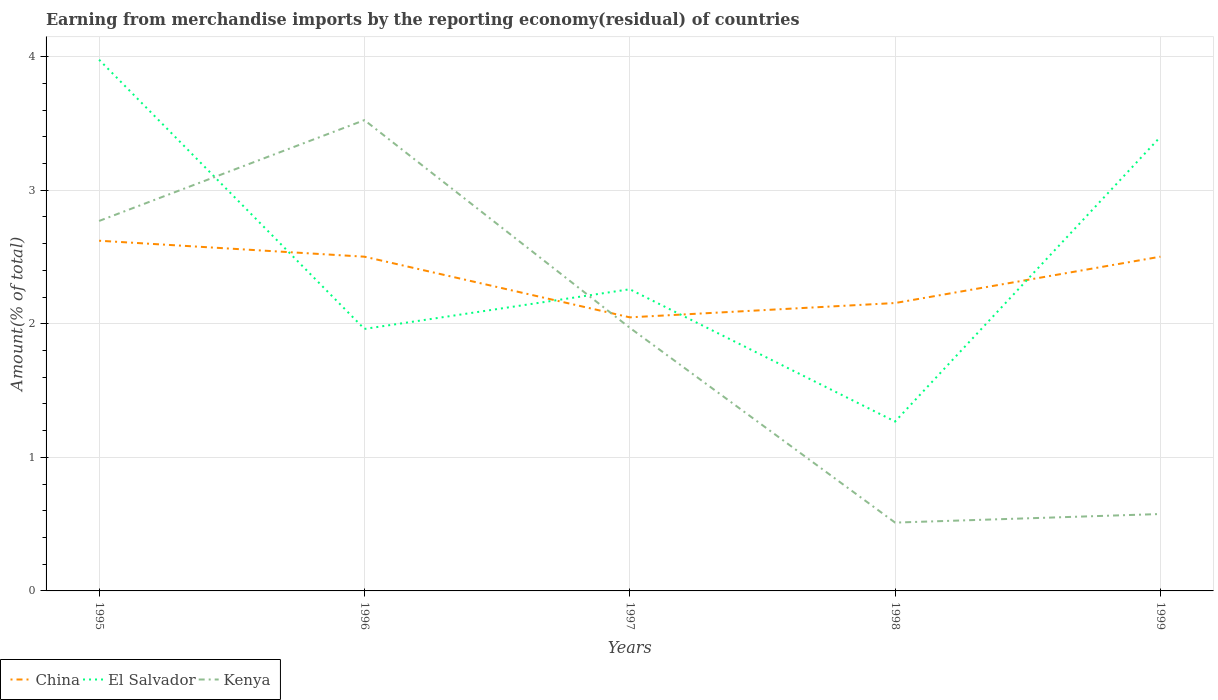Is the number of lines equal to the number of legend labels?
Offer a terse response. Yes. Across all years, what is the maximum percentage of amount earned from merchandise imports in Kenya?
Provide a short and direct response. 0.51. In which year was the percentage of amount earned from merchandise imports in China maximum?
Offer a terse response. 1997. What is the total percentage of amount earned from merchandise imports in Kenya in the graph?
Make the answer very short. 1.55. What is the difference between the highest and the second highest percentage of amount earned from merchandise imports in El Salvador?
Ensure brevity in your answer.  2.71. What is the difference between the highest and the lowest percentage of amount earned from merchandise imports in El Salvador?
Your response must be concise. 2. Is the percentage of amount earned from merchandise imports in El Salvador strictly greater than the percentage of amount earned from merchandise imports in China over the years?
Your answer should be very brief. No. How many lines are there?
Keep it short and to the point. 3. What is the difference between two consecutive major ticks on the Y-axis?
Offer a very short reply. 1. Does the graph contain any zero values?
Offer a terse response. No. Where does the legend appear in the graph?
Make the answer very short. Bottom left. How many legend labels are there?
Ensure brevity in your answer.  3. How are the legend labels stacked?
Provide a succinct answer. Horizontal. What is the title of the graph?
Your response must be concise. Earning from merchandise imports by the reporting economy(residual) of countries. What is the label or title of the Y-axis?
Make the answer very short. Amount(% of total). What is the Amount(% of total) in China in 1995?
Offer a very short reply. 2.62. What is the Amount(% of total) in El Salvador in 1995?
Your answer should be very brief. 3.98. What is the Amount(% of total) of Kenya in 1995?
Provide a short and direct response. 2.77. What is the Amount(% of total) of China in 1996?
Offer a terse response. 2.5. What is the Amount(% of total) of El Salvador in 1996?
Keep it short and to the point. 1.96. What is the Amount(% of total) of Kenya in 1996?
Your answer should be compact. 3.53. What is the Amount(% of total) of China in 1997?
Ensure brevity in your answer.  2.05. What is the Amount(% of total) of El Salvador in 1997?
Your answer should be very brief. 2.26. What is the Amount(% of total) in Kenya in 1997?
Ensure brevity in your answer.  1.97. What is the Amount(% of total) of China in 1998?
Your answer should be compact. 2.16. What is the Amount(% of total) in El Salvador in 1998?
Keep it short and to the point. 1.27. What is the Amount(% of total) of Kenya in 1998?
Ensure brevity in your answer.  0.51. What is the Amount(% of total) of China in 1999?
Your response must be concise. 2.5. What is the Amount(% of total) of El Salvador in 1999?
Offer a very short reply. 3.4. What is the Amount(% of total) of Kenya in 1999?
Keep it short and to the point. 0.58. Across all years, what is the maximum Amount(% of total) in China?
Ensure brevity in your answer.  2.62. Across all years, what is the maximum Amount(% of total) of El Salvador?
Offer a very short reply. 3.98. Across all years, what is the maximum Amount(% of total) of Kenya?
Give a very brief answer. 3.53. Across all years, what is the minimum Amount(% of total) in China?
Ensure brevity in your answer.  2.05. Across all years, what is the minimum Amount(% of total) in El Salvador?
Your answer should be very brief. 1.27. Across all years, what is the minimum Amount(% of total) of Kenya?
Give a very brief answer. 0.51. What is the total Amount(% of total) in China in the graph?
Provide a short and direct response. 11.83. What is the total Amount(% of total) in El Salvador in the graph?
Offer a very short reply. 12.87. What is the total Amount(% of total) in Kenya in the graph?
Provide a succinct answer. 9.35. What is the difference between the Amount(% of total) of China in 1995 and that in 1996?
Offer a terse response. 0.12. What is the difference between the Amount(% of total) of El Salvador in 1995 and that in 1996?
Offer a very short reply. 2.02. What is the difference between the Amount(% of total) in Kenya in 1995 and that in 1996?
Your answer should be very brief. -0.76. What is the difference between the Amount(% of total) in China in 1995 and that in 1997?
Provide a short and direct response. 0.57. What is the difference between the Amount(% of total) in El Salvador in 1995 and that in 1997?
Make the answer very short. 1.72. What is the difference between the Amount(% of total) of Kenya in 1995 and that in 1997?
Your answer should be very brief. 0.8. What is the difference between the Amount(% of total) of China in 1995 and that in 1998?
Provide a succinct answer. 0.47. What is the difference between the Amount(% of total) in El Salvador in 1995 and that in 1998?
Provide a succinct answer. 2.71. What is the difference between the Amount(% of total) of Kenya in 1995 and that in 1998?
Ensure brevity in your answer.  2.26. What is the difference between the Amount(% of total) in China in 1995 and that in 1999?
Make the answer very short. 0.12. What is the difference between the Amount(% of total) in El Salvador in 1995 and that in 1999?
Ensure brevity in your answer.  0.58. What is the difference between the Amount(% of total) in Kenya in 1995 and that in 1999?
Provide a short and direct response. 2.19. What is the difference between the Amount(% of total) of China in 1996 and that in 1997?
Your answer should be compact. 0.45. What is the difference between the Amount(% of total) of El Salvador in 1996 and that in 1997?
Your answer should be very brief. -0.3. What is the difference between the Amount(% of total) in Kenya in 1996 and that in 1997?
Your answer should be very brief. 1.55. What is the difference between the Amount(% of total) in China in 1996 and that in 1998?
Your answer should be compact. 0.35. What is the difference between the Amount(% of total) of El Salvador in 1996 and that in 1998?
Keep it short and to the point. 0.69. What is the difference between the Amount(% of total) in Kenya in 1996 and that in 1998?
Your answer should be very brief. 3.01. What is the difference between the Amount(% of total) of China in 1996 and that in 1999?
Provide a short and direct response. -0. What is the difference between the Amount(% of total) of El Salvador in 1996 and that in 1999?
Make the answer very short. -1.44. What is the difference between the Amount(% of total) in Kenya in 1996 and that in 1999?
Give a very brief answer. 2.95. What is the difference between the Amount(% of total) in China in 1997 and that in 1998?
Provide a short and direct response. -0.11. What is the difference between the Amount(% of total) in El Salvador in 1997 and that in 1998?
Your answer should be very brief. 0.99. What is the difference between the Amount(% of total) in Kenya in 1997 and that in 1998?
Make the answer very short. 1.46. What is the difference between the Amount(% of total) of China in 1997 and that in 1999?
Provide a short and direct response. -0.45. What is the difference between the Amount(% of total) of El Salvador in 1997 and that in 1999?
Your answer should be compact. -1.14. What is the difference between the Amount(% of total) in Kenya in 1997 and that in 1999?
Your response must be concise. 1.39. What is the difference between the Amount(% of total) of China in 1998 and that in 1999?
Offer a terse response. -0.35. What is the difference between the Amount(% of total) of El Salvador in 1998 and that in 1999?
Offer a very short reply. -2.13. What is the difference between the Amount(% of total) of Kenya in 1998 and that in 1999?
Your response must be concise. -0.06. What is the difference between the Amount(% of total) of China in 1995 and the Amount(% of total) of El Salvador in 1996?
Offer a very short reply. 0.66. What is the difference between the Amount(% of total) of China in 1995 and the Amount(% of total) of Kenya in 1996?
Offer a terse response. -0.9. What is the difference between the Amount(% of total) in El Salvador in 1995 and the Amount(% of total) in Kenya in 1996?
Make the answer very short. 0.45. What is the difference between the Amount(% of total) in China in 1995 and the Amount(% of total) in El Salvador in 1997?
Offer a terse response. 0.36. What is the difference between the Amount(% of total) of China in 1995 and the Amount(% of total) of Kenya in 1997?
Your answer should be very brief. 0.65. What is the difference between the Amount(% of total) in El Salvador in 1995 and the Amount(% of total) in Kenya in 1997?
Ensure brevity in your answer.  2.01. What is the difference between the Amount(% of total) of China in 1995 and the Amount(% of total) of El Salvador in 1998?
Your answer should be compact. 1.35. What is the difference between the Amount(% of total) of China in 1995 and the Amount(% of total) of Kenya in 1998?
Provide a succinct answer. 2.11. What is the difference between the Amount(% of total) in El Salvador in 1995 and the Amount(% of total) in Kenya in 1998?
Make the answer very short. 3.47. What is the difference between the Amount(% of total) in China in 1995 and the Amount(% of total) in El Salvador in 1999?
Ensure brevity in your answer.  -0.78. What is the difference between the Amount(% of total) in China in 1995 and the Amount(% of total) in Kenya in 1999?
Offer a very short reply. 2.05. What is the difference between the Amount(% of total) of El Salvador in 1995 and the Amount(% of total) of Kenya in 1999?
Offer a terse response. 3.4. What is the difference between the Amount(% of total) in China in 1996 and the Amount(% of total) in El Salvador in 1997?
Make the answer very short. 0.24. What is the difference between the Amount(% of total) of China in 1996 and the Amount(% of total) of Kenya in 1997?
Provide a succinct answer. 0.53. What is the difference between the Amount(% of total) of El Salvador in 1996 and the Amount(% of total) of Kenya in 1997?
Provide a succinct answer. -0.01. What is the difference between the Amount(% of total) of China in 1996 and the Amount(% of total) of El Salvador in 1998?
Your response must be concise. 1.23. What is the difference between the Amount(% of total) of China in 1996 and the Amount(% of total) of Kenya in 1998?
Make the answer very short. 1.99. What is the difference between the Amount(% of total) in El Salvador in 1996 and the Amount(% of total) in Kenya in 1998?
Offer a very short reply. 1.45. What is the difference between the Amount(% of total) in China in 1996 and the Amount(% of total) in El Salvador in 1999?
Offer a terse response. -0.9. What is the difference between the Amount(% of total) of China in 1996 and the Amount(% of total) of Kenya in 1999?
Your response must be concise. 1.93. What is the difference between the Amount(% of total) in El Salvador in 1996 and the Amount(% of total) in Kenya in 1999?
Your response must be concise. 1.39. What is the difference between the Amount(% of total) in China in 1997 and the Amount(% of total) in El Salvador in 1998?
Provide a succinct answer. 0.78. What is the difference between the Amount(% of total) of China in 1997 and the Amount(% of total) of Kenya in 1998?
Keep it short and to the point. 1.54. What is the difference between the Amount(% of total) of El Salvador in 1997 and the Amount(% of total) of Kenya in 1998?
Offer a very short reply. 1.75. What is the difference between the Amount(% of total) of China in 1997 and the Amount(% of total) of El Salvador in 1999?
Offer a terse response. -1.35. What is the difference between the Amount(% of total) of China in 1997 and the Amount(% of total) of Kenya in 1999?
Your answer should be very brief. 1.47. What is the difference between the Amount(% of total) of El Salvador in 1997 and the Amount(% of total) of Kenya in 1999?
Provide a succinct answer. 1.68. What is the difference between the Amount(% of total) in China in 1998 and the Amount(% of total) in El Salvador in 1999?
Ensure brevity in your answer.  -1.24. What is the difference between the Amount(% of total) in China in 1998 and the Amount(% of total) in Kenya in 1999?
Keep it short and to the point. 1.58. What is the difference between the Amount(% of total) of El Salvador in 1998 and the Amount(% of total) of Kenya in 1999?
Make the answer very short. 0.69. What is the average Amount(% of total) in China per year?
Make the answer very short. 2.37. What is the average Amount(% of total) in El Salvador per year?
Keep it short and to the point. 2.57. What is the average Amount(% of total) of Kenya per year?
Your response must be concise. 1.87. In the year 1995, what is the difference between the Amount(% of total) of China and Amount(% of total) of El Salvador?
Give a very brief answer. -1.36. In the year 1995, what is the difference between the Amount(% of total) in China and Amount(% of total) in Kenya?
Your answer should be very brief. -0.15. In the year 1995, what is the difference between the Amount(% of total) in El Salvador and Amount(% of total) in Kenya?
Provide a short and direct response. 1.21. In the year 1996, what is the difference between the Amount(% of total) in China and Amount(% of total) in El Salvador?
Ensure brevity in your answer.  0.54. In the year 1996, what is the difference between the Amount(% of total) in China and Amount(% of total) in Kenya?
Offer a very short reply. -1.02. In the year 1996, what is the difference between the Amount(% of total) in El Salvador and Amount(% of total) in Kenya?
Offer a very short reply. -1.56. In the year 1997, what is the difference between the Amount(% of total) of China and Amount(% of total) of El Salvador?
Offer a terse response. -0.21. In the year 1997, what is the difference between the Amount(% of total) in China and Amount(% of total) in Kenya?
Give a very brief answer. 0.08. In the year 1997, what is the difference between the Amount(% of total) in El Salvador and Amount(% of total) in Kenya?
Keep it short and to the point. 0.29. In the year 1998, what is the difference between the Amount(% of total) of China and Amount(% of total) of El Salvador?
Keep it short and to the point. 0.89. In the year 1998, what is the difference between the Amount(% of total) of China and Amount(% of total) of Kenya?
Keep it short and to the point. 1.64. In the year 1998, what is the difference between the Amount(% of total) of El Salvador and Amount(% of total) of Kenya?
Make the answer very short. 0.76. In the year 1999, what is the difference between the Amount(% of total) in China and Amount(% of total) in El Salvador?
Give a very brief answer. -0.9. In the year 1999, what is the difference between the Amount(% of total) in China and Amount(% of total) in Kenya?
Offer a very short reply. 1.93. In the year 1999, what is the difference between the Amount(% of total) of El Salvador and Amount(% of total) of Kenya?
Ensure brevity in your answer.  2.82. What is the ratio of the Amount(% of total) in China in 1995 to that in 1996?
Your answer should be very brief. 1.05. What is the ratio of the Amount(% of total) in El Salvador in 1995 to that in 1996?
Your response must be concise. 2.03. What is the ratio of the Amount(% of total) in Kenya in 1995 to that in 1996?
Keep it short and to the point. 0.79. What is the ratio of the Amount(% of total) of China in 1995 to that in 1997?
Your response must be concise. 1.28. What is the ratio of the Amount(% of total) of El Salvador in 1995 to that in 1997?
Provide a short and direct response. 1.76. What is the ratio of the Amount(% of total) in Kenya in 1995 to that in 1997?
Ensure brevity in your answer.  1.41. What is the ratio of the Amount(% of total) of China in 1995 to that in 1998?
Provide a short and direct response. 1.22. What is the ratio of the Amount(% of total) of El Salvador in 1995 to that in 1998?
Make the answer very short. 3.14. What is the ratio of the Amount(% of total) of Kenya in 1995 to that in 1998?
Your answer should be very brief. 5.41. What is the ratio of the Amount(% of total) in China in 1995 to that in 1999?
Your answer should be compact. 1.05. What is the ratio of the Amount(% of total) of El Salvador in 1995 to that in 1999?
Offer a very short reply. 1.17. What is the ratio of the Amount(% of total) in Kenya in 1995 to that in 1999?
Offer a very short reply. 4.81. What is the ratio of the Amount(% of total) in China in 1996 to that in 1997?
Provide a short and direct response. 1.22. What is the ratio of the Amount(% of total) of El Salvador in 1996 to that in 1997?
Offer a very short reply. 0.87. What is the ratio of the Amount(% of total) of Kenya in 1996 to that in 1997?
Provide a short and direct response. 1.79. What is the ratio of the Amount(% of total) of China in 1996 to that in 1998?
Your answer should be very brief. 1.16. What is the ratio of the Amount(% of total) in El Salvador in 1996 to that in 1998?
Your answer should be compact. 1.55. What is the ratio of the Amount(% of total) in Kenya in 1996 to that in 1998?
Offer a terse response. 6.89. What is the ratio of the Amount(% of total) in China in 1996 to that in 1999?
Make the answer very short. 1. What is the ratio of the Amount(% of total) in El Salvador in 1996 to that in 1999?
Offer a terse response. 0.58. What is the ratio of the Amount(% of total) of Kenya in 1996 to that in 1999?
Offer a terse response. 6.12. What is the ratio of the Amount(% of total) of China in 1997 to that in 1998?
Offer a terse response. 0.95. What is the ratio of the Amount(% of total) of El Salvador in 1997 to that in 1998?
Make the answer very short. 1.78. What is the ratio of the Amount(% of total) in Kenya in 1997 to that in 1998?
Give a very brief answer. 3.85. What is the ratio of the Amount(% of total) of China in 1997 to that in 1999?
Provide a short and direct response. 0.82. What is the ratio of the Amount(% of total) in El Salvador in 1997 to that in 1999?
Give a very brief answer. 0.66. What is the ratio of the Amount(% of total) of Kenya in 1997 to that in 1999?
Make the answer very short. 3.42. What is the ratio of the Amount(% of total) of China in 1998 to that in 1999?
Offer a terse response. 0.86. What is the ratio of the Amount(% of total) of El Salvador in 1998 to that in 1999?
Make the answer very short. 0.37. What is the ratio of the Amount(% of total) in Kenya in 1998 to that in 1999?
Keep it short and to the point. 0.89. What is the difference between the highest and the second highest Amount(% of total) in China?
Your answer should be very brief. 0.12. What is the difference between the highest and the second highest Amount(% of total) in El Salvador?
Give a very brief answer. 0.58. What is the difference between the highest and the second highest Amount(% of total) in Kenya?
Provide a succinct answer. 0.76. What is the difference between the highest and the lowest Amount(% of total) of China?
Your response must be concise. 0.57. What is the difference between the highest and the lowest Amount(% of total) of El Salvador?
Your answer should be very brief. 2.71. What is the difference between the highest and the lowest Amount(% of total) of Kenya?
Offer a terse response. 3.01. 